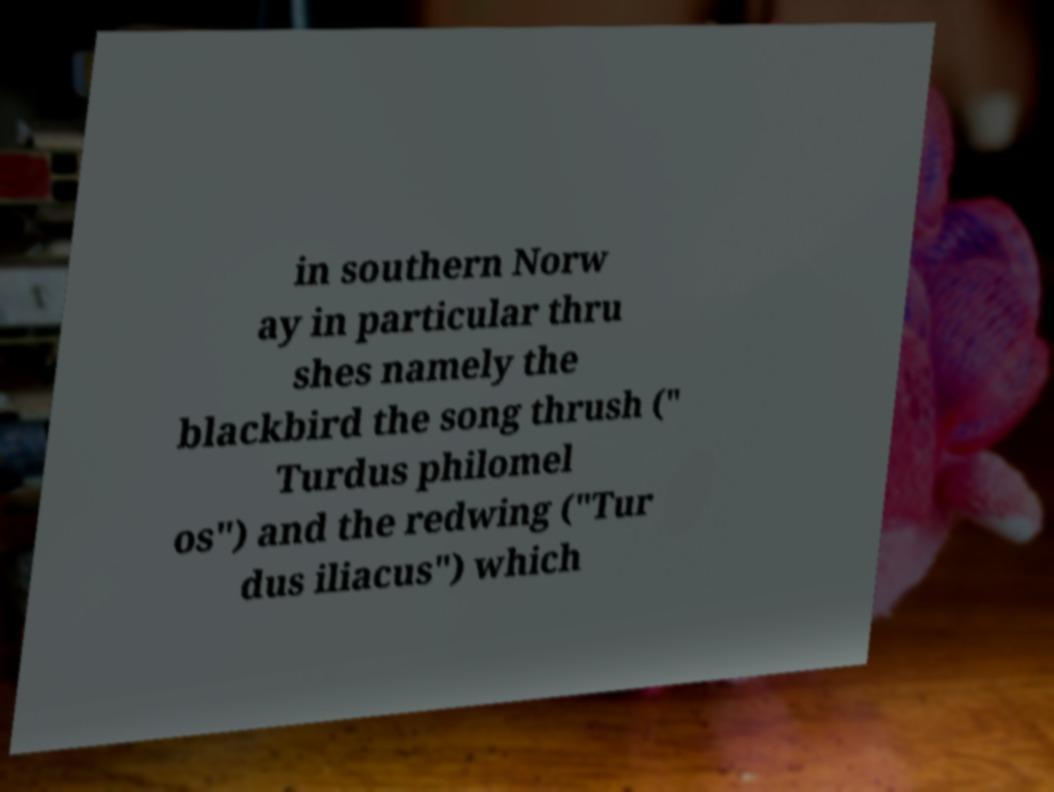Please identify and transcribe the text found in this image. in southern Norw ay in particular thru shes namely the blackbird the song thrush (" Turdus philomel os") and the redwing ("Tur dus iliacus") which 